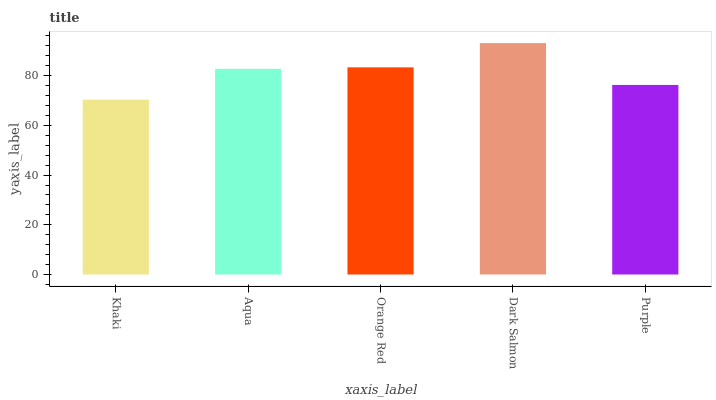Is Khaki the minimum?
Answer yes or no. Yes. Is Dark Salmon the maximum?
Answer yes or no. Yes. Is Aqua the minimum?
Answer yes or no. No. Is Aqua the maximum?
Answer yes or no. No. Is Aqua greater than Khaki?
Answer yes or no. Yes. Is Khaki less than Aqua?
Answer yes or no. Yes. Is Khaki greater than Aqua?
Answer yes or no. No. Is Aqua less than Khaki?
Answer yes or no. No. Is Aqua the high median?
Answer yes or no. Yes. Is Aqua the low median?
Answer yes or no. Yes. Is Orange Red the high median?
Answer yes or no. No. Is Dark Salmon the low median?
Answer yes or no. No. 